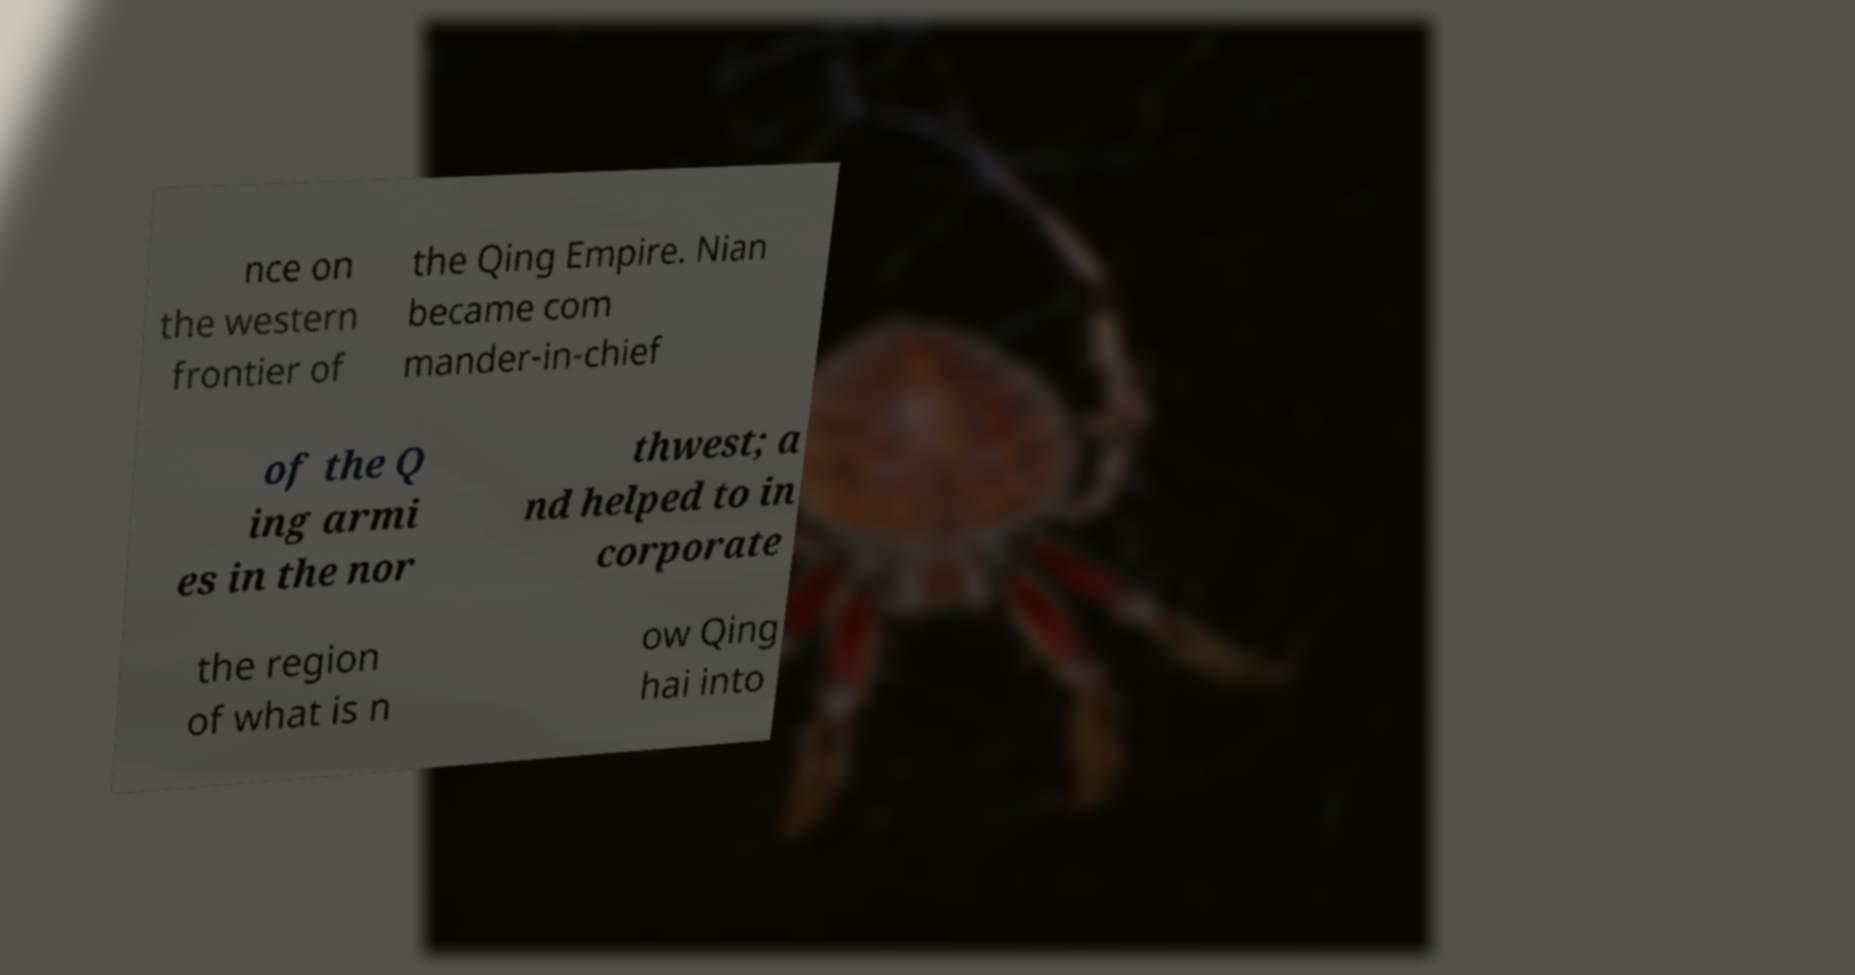Could you extract and type out the text from this image? nce on the western frontier of the Qing Empire. Nian became com mander-in-chief of the Q ing armi es in the nor thwest; a nd helped to in corporate the region of what is n ow Qing hai into 